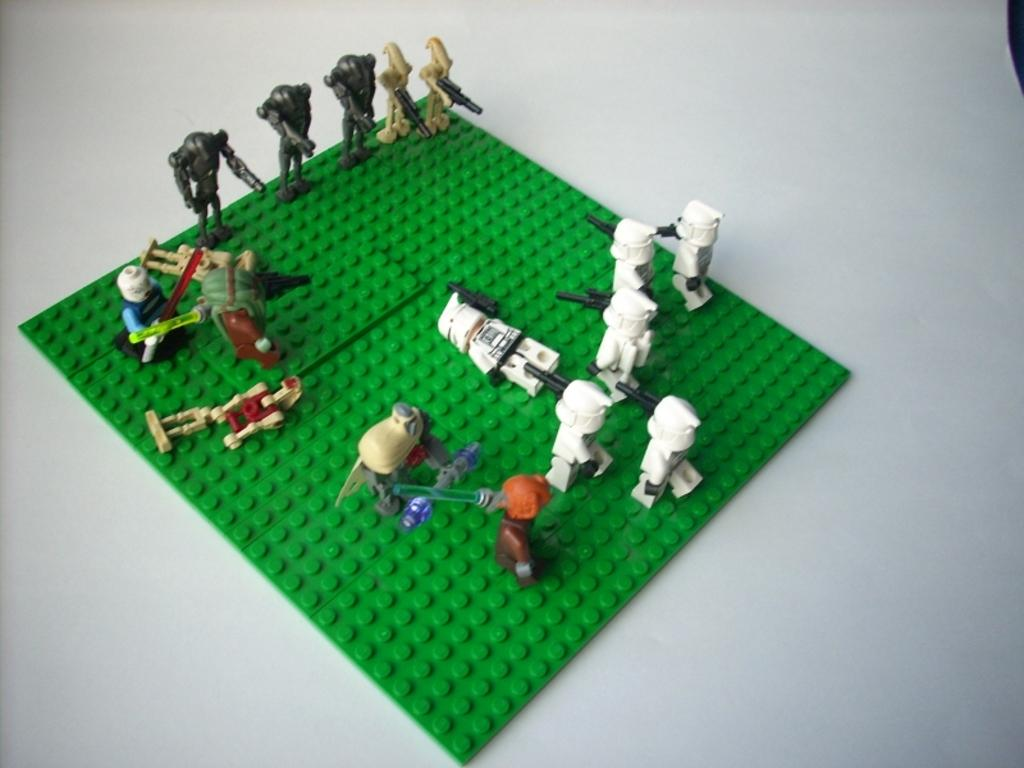What type of toys are visible in the image? There are lego toys in the image. What color is the background of the image? The background of the image is white. Where is the robin perched in the image? There is no robin present in the image; it only features lego toys. How many ants can be seen crawling on the lego toys in the image? There are no ants visible in the image; it only features lego toys. 